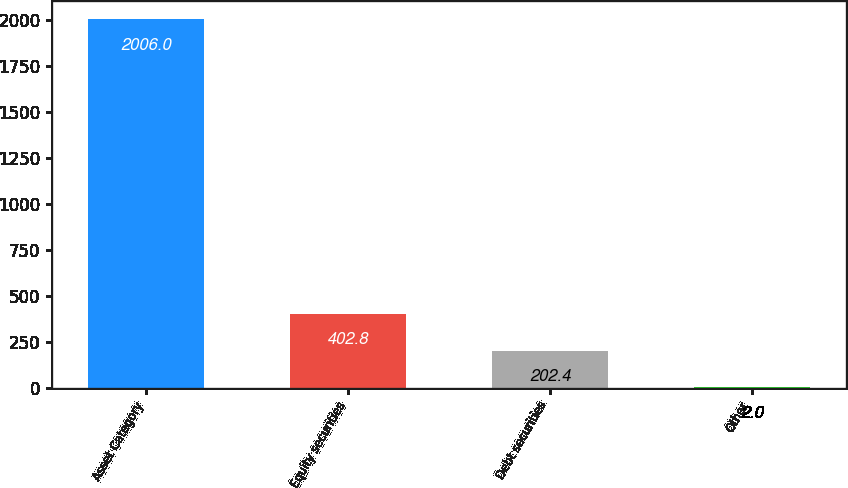Convert chart. <chart><loc_0><loc_0><loc_500><loc_500><bar_chart><fcel>Asset Category<fcel>Equity securities<fcel>Debt securities<fcel>Other<nl><fcel>2006<fcel>402.8<fcel>202.4<fcel>2<nl></chart> 